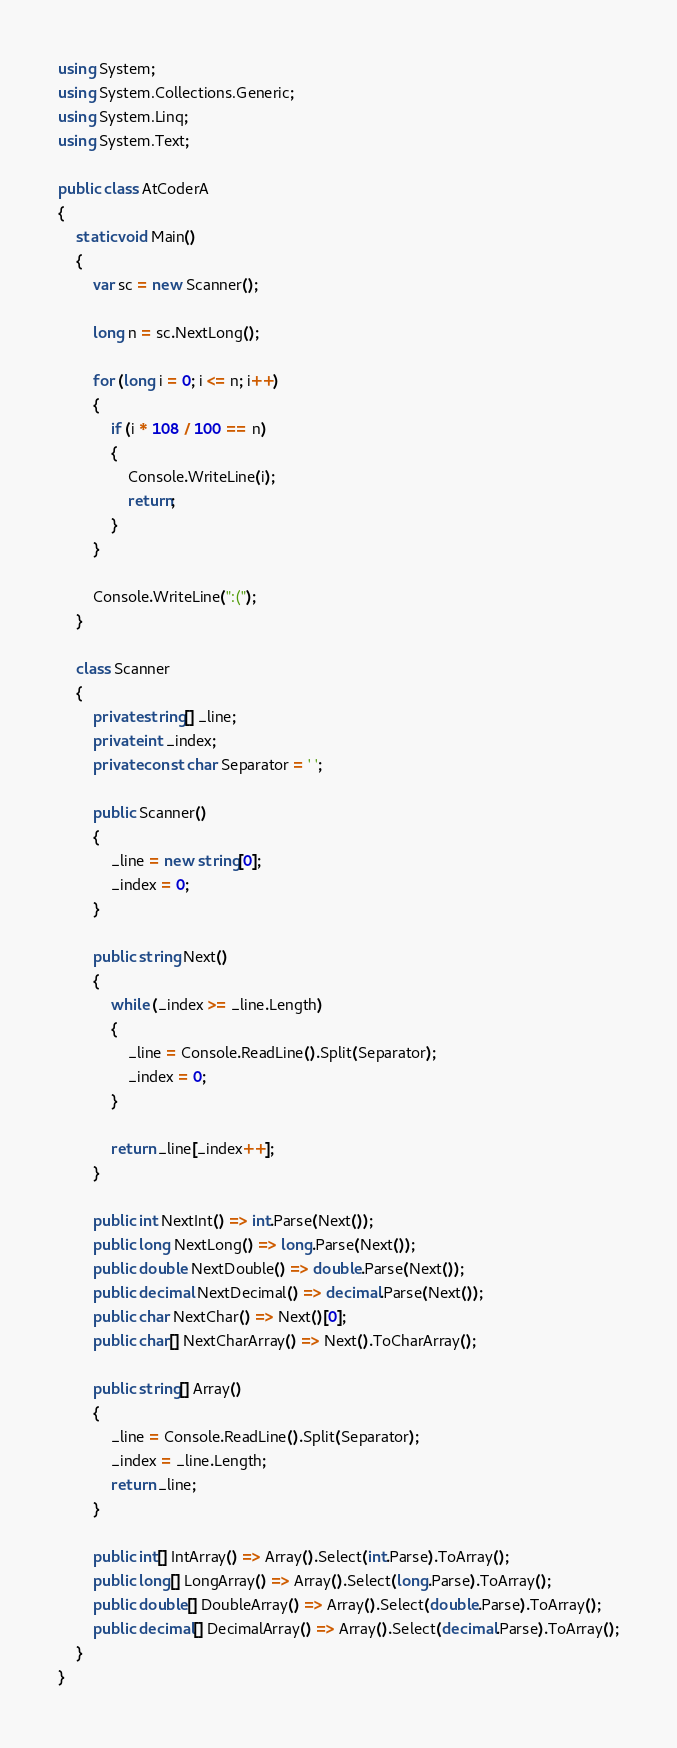<code> <loc_0><loc_0><loc_500><loc_500><_C#_>using System;
using System.Collections.Generic;
using System.Linq;
using System.Text;

public class AtCoderA
{
    static void Main()
    {
        var sc = new Scanner();

        long n = sc.NextLong();

        for (long i = 0; i <= n; i++)
        {
            if (i * 108 / 100 == n)
            {
                Console.WriteLine(i);
                return;
            }
        }

        Console.WriteLine(":(");
    }

    class Scanner
    {
        private string[] _line;
        private int _index;
        private const char Separator = ' ';

        public Scanner()
        {
            _line = new string[0];
            _index = 0;
        }

        public string Next()
        {
            while (_index >= _line.Length)
            {
                _line = Console.ReadLine().Split(Separator);
                _index = 0;
            }

            return _line[_index++];
        }

        public int NextInt() => int.Parse(Next());
        public long NextLong() => long.Parse(Next());
        public double NextDouble() => double.Parse(Next());
        public decimal NextDecimal() => decimal.Parse(Next());
        public char NextChar() => Next()[0];
        public char[] NextCharArray() => Next().ToCharArray();

        public string[] Array()
        {
            _line = Console.ReadLine().Split(Separator);
            _index = _line.Length;
            return _line;
        }

        public int[] IntArray() => Array().Select(int.Parse).ToArray();
        public long[] LongArray() => Array().Select(long.Parse).ToArray();
        public double[] DoubleArray() => Array().Select(double.Parse).ToArray();
        public decimal[] DecimalArray() => Array().Select(decimal.Parse).ToArray();
    }
}
</code> 